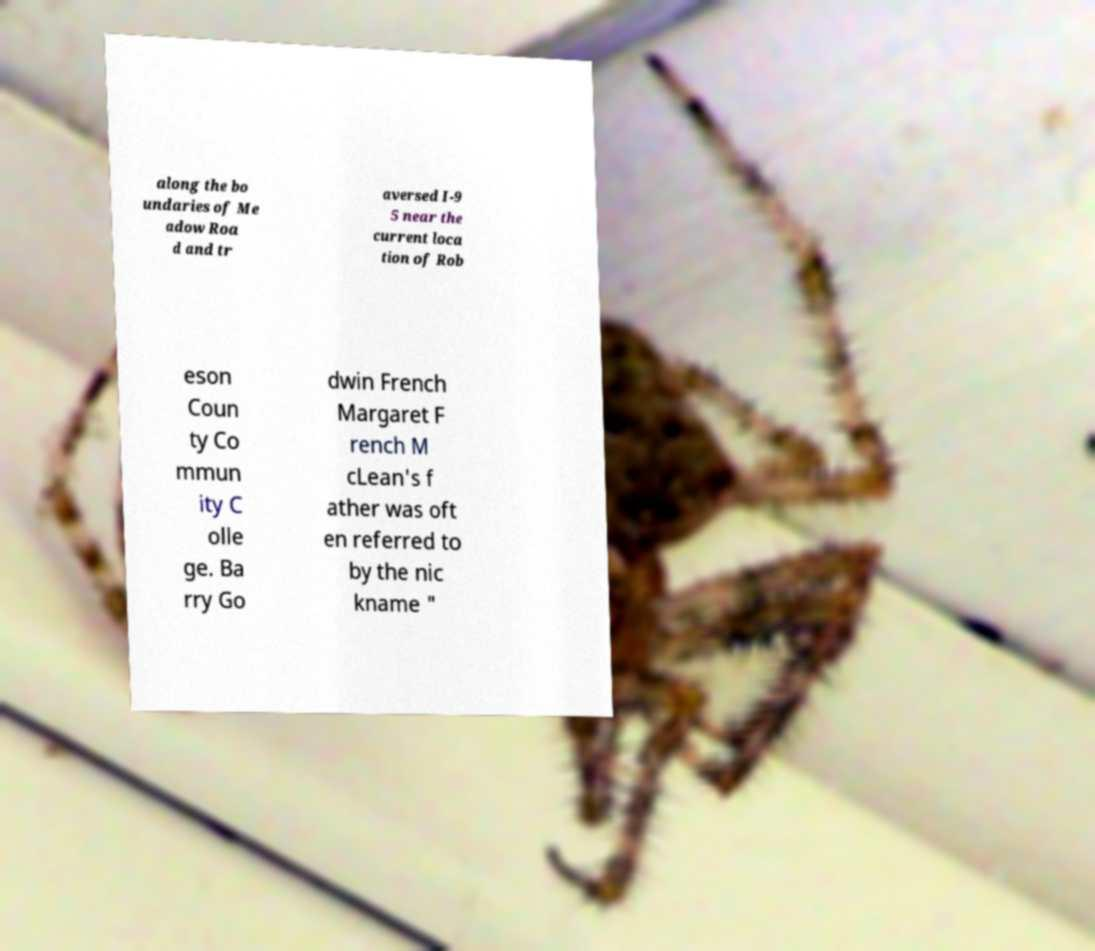What messages or text are displayed in this image? I need them in a readable, typed format. along the bo undaries of Me adow Roa d and tr aversed I-9 5 near the current loca tion of Rob eson Coun ty Co mmun ity C olle ge. Ba rry Go dwin French Margaret F rench M cLean's f ather was oft en referred to by the nic kname " 